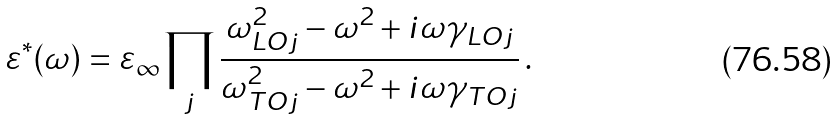Convert formula to latex. <formula><loc_0><loc_0><loc_500><loc_500>\varepsilon ^ { * } ( \omega ) = \varepsilon _ { \infty } \prod _ { j } \frac { \omega ^ { 2 } _ { L O j } - \omega ^ { 2 } + i \omega \gamma _ { L O j } } { \omega ^ { 2 } _ { T O j } - \omega ^ { 2 } + i \omega \gamma _ { T O j } } \, .</formula> 